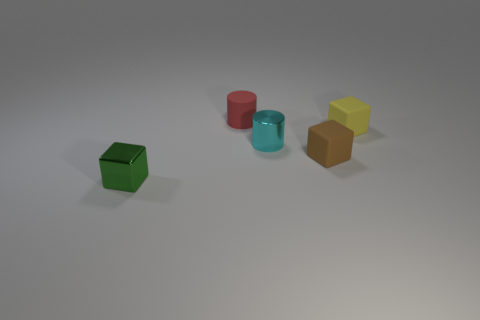Subtract all small matte cubes. How many cubes are left? 1 Subtract 1 blocks. How many blocks are left? 2 Subtract all brown blocks. How many blocks are left? 2 Add 1 matte things. How many objects exist? 6 Subtract all blocks. How many objects are left? 2 Subtract all small green blocks. Subtract all red rubber things. How many objects are left? 3 Add 4 tiny cyan cylinders. How many tiny cyan cylinders are left? 5 Add 2 metallic blocks. How many metallic blocks exist? 3 Subtract 1 red cylinders. How many objects are left? 4 Subtract all green cylinders. Subtract all yellow cubes. How many cylinders are left? 2 